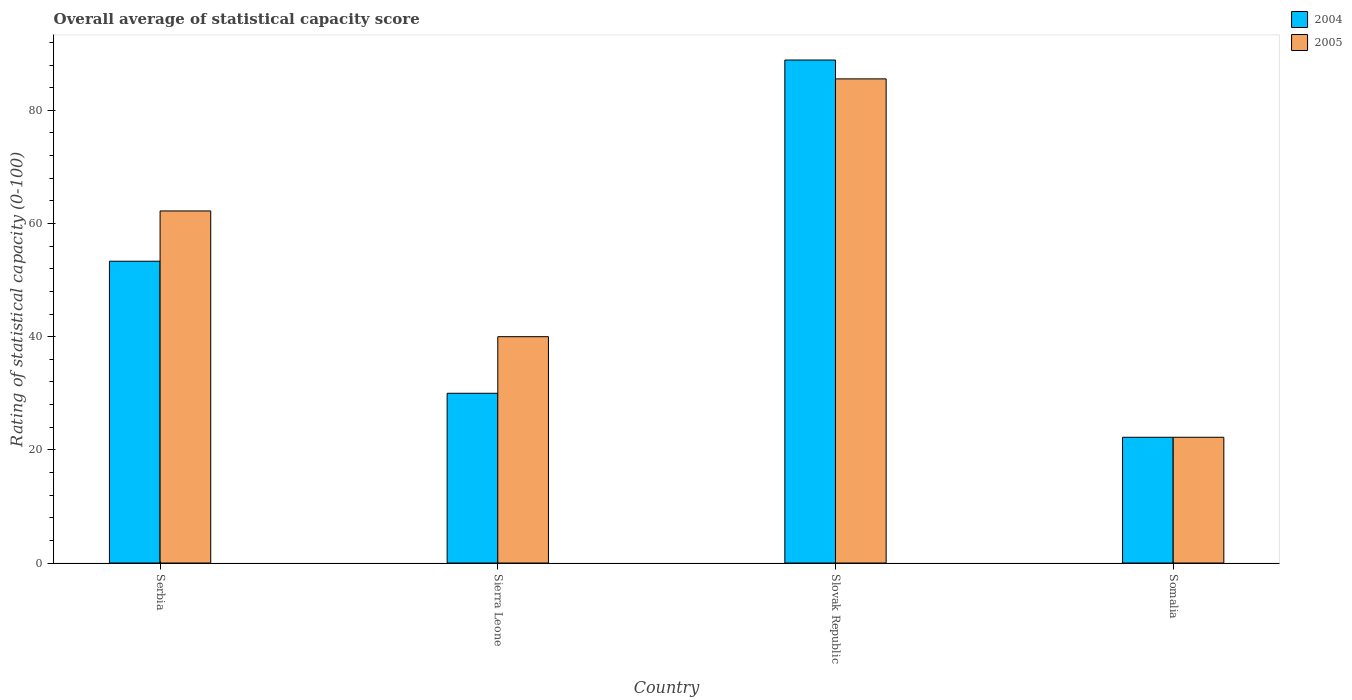How many different coloured bars are there?
Give a very brief answer. 2. How many groups of bars are there?
Your answer should be compact. 4. How many bars are there on the 1st tick from the left?
Give a very brief answer. 2. How many bars are there on the 1st tick from the right?
Your answer should be very brief. 2. What is the label of the 4th group of bars from the left?
Your answer should be compact. Somalia. In how many cases, is the number of bars for a given country not equal to the number of legend labels?
Give a very brief answer. 0. What is the rating of statistical capacity in 2005 in Slovak Republic?
Your answer should be compact. 85.56. Across all countries, what is the maximum rating of statistical capacity in 2004?
Offer a very short reply. 88.89. Across all countries, what is the minimum rating of statistical capacity in 2004?
Ensure brevity in your answer.  22.22. In which country was the rating of statistical capacity in 2005 maximum?
Provide a succinct answer. Slovak Republic. In which country was the rating of statistical capacity in 2005 minimum?
Ensure brevity in your answer.  Somalia. What is the total rating of statistical capacity in 2004 in the graph?
Your answer should be very brief. 194.44. What is the difference between the rating of statistical capacity in 2004 in Slovak Republic and that in Somalia?
Your answer should be compact. 66.67. What is the difference between the rating of statistical capacity in 2004 in Sierra Leone and the rating of statistical capacity in 2005 in Somalia?
Make the answer very short. 7.78. What is the average rating of statistical capacity in 2005 per country?
Ensure brevity in your answer.  52.5. What is the difference between the rating of statistical capacity of/in 2004 and rating of statistical capacity of/in 2005 in Serbia?
Offer a very short reply. -8.89. In how many countries, is the rating of statistical capacity in 2005 greater than 52?
Make the answer very short. 2. What is the ratio of the rating of statistical capacity in 2004 in Sierra Leone to that in Somalia?
Offer a very short reply. 1.35. Is the rating of statistical capacity in 2004 in Serbia less than that in Slovak Republic?
Your response must be concise. Yes. Is the difference between the rating of statistical capacity in 2004 in Sierra Leone and Slovak Republic greater than the difference between the rating of statistical capacity in 2005 in Sierra Leone and Slovak Republic?
Your answer should be compact. No. What is the difference between the highest and the second highest rating of statistical capacity in 2005?
Provide a short and direct response. -45.56. What is the difference between the highest and the lowest rating of statistical capacity in 2005?
Offer a very short reply. 63.33. What does the 1st bar from the left in Sierra Leone represents?
Ensure brevity in your answer.  2004. How many countries are there in the graph?
Ensure brevity in your answer.  4. Are the values on the major ticks of Y-axis written in scientific E-notation?
Your answer should be compact. No. Does the graph contain grids?
Offer a terse response. No. Where does the legend appear in the graph?
Provide a succinct answer. Top right. How are the legend labels stacked?
Keep it short and to the point. Vertical. What is the title of the graph?
Provide a short and direct response. Overall average of statistical capacity score. Does "1973" appear as one of the legend labels in the graph?
Ensure brevity in your answer.  No. What is the label or title of the Y-axis?
Make the answer very short. Rating of statistical capacity (0-100). What is the Rating of statistical capacity (0-100) of 2004 in Serbia?
Ensure brevity in your answer.  53.33. What is the Rating of statistical capacity (0-100) in 2005 in Serbia?
Make the answer very short. 62.22. What is the Rating of statistical capacity (0-100) of 2005 in Sierra Leone?
Provide a succinct answer. 40. What is the Rating of statistical capacity (0-100) in 2004 in Slovak Republic?
Your response must be concise. 88.89. What is the Rating of statistical capacity (0-100) of 2005 in Slovak Republic?
Provide a succinct answer. 85.56. What is the Rating of statistical capacity (0-100) of 2004 in Somalia?
Your answer should be compact. 22.22. What is the Rating of statistical capacity (0-100) in 2005 in Somalia?
Your response must be concise. 22.22. Across all countries, what is the maximum Rating of statistical capacity (0-100) of 2004?
Your answer should be very brief. 88.89. Across all countries, what is the maximum Rating of statistical capacity (0-100) in 2005?
Provide a succinct answer. 85.56. Across all countries, what is the minimum Rating of statistical capacity (0-100) of 2004?
Make the answer very short. 22.22. Across all countries, what is the minimum Rating of statistical capacity (0-100) in 2005?
Your answer should be very brief. 22.22. What is the total Rating of statistical capacity (0-100) in 2004 in the graph?
Your response must be concise. 194.44. What is the total Rating of statistical capacity (0-100) of 2005 in the graph?
Give a very brief answer. 210. What is the difference between the Rating of statistical capacity (0-100) in 2004 in Serbia and that in Sierra Leone?
Make the answer very short. 23.33. What is the difference between the Rating of statistical capacity (0-100) in 2005 in Serbia and that in Sierra Leone?
Give a very brief answer. 22.22. What is the difference between the Rating of statistical capacity (0-100) of 2004 in Serbia and that in Slovak Republic?
Your response must be concise. -35.56. What is the difference between the Rating of statistical capacity (0-100) in 2005 in Serbia and that in Slovak Republic?
Provide a succinct answer. -23.34. What is the difference between the Rating of statistical capacity (0-100) of 2004 in Serbia and that in Somalia?
Give a very brief answer. 31.11. What is the difference between the Rating of statistical capacity (0-100) of 2005 in Serbia and that in Somalia?
Your answer should be compact. 40. What is the difference between the Rating of statistical capacity (0-100) in 2004 in Sierra Leone and that in Slovak Republic?
Ensure brevity in your answer.  -58.89. What is the difference between the Rating of statistical capacity (0-100) in 2005 in Sierra Leone and that in Slovak Republic?
Provide a short and direct response. -45.56. What is the difference between the Rating of statistical capacity (0-100) of 2004 in Sierra Leone and that in Somalia?
Provide a short and direct response. 7.78. What is the difference between the Rating of statistical capacity (0-100) of 2005 in Sierra Leone and that in Somalia?
Make the answer very short. 17.78. What is the difference between the Rating of statistical capacity (0-100) of 2004 in Slovak Republic and that in Somalia?
Give a very brief answer. 66.67. What is the difference between the Rating of statistical capacity (0-100) in 2005 in Slovak Republic and that in Somalia?
Make the answer very short. 63.33. What is the difference between the Rating of statistical capacity (0-100) of 2004 in Serbia and the Rating of statistical capacity (0-100) of 2005 in Sierra Leone?
Make the answer very short. 13.33. What is the difference between the Rating of statistical capacity (0-100) in 2004 in Serbia and the Rating of statistical capacity (0-100) in 2005 in Slovak Republic?
Provide a succinct answer. -32.22. What is the difference between the Rating of statistical capacity (0-100) of 2004 in Serbia and the Rating of statistical capacity (0-100) of 2005 in Somalia?
Your answer should be very brief. 31.11. What is the difference between the Rating of statistical capacity (0-100) in 2004 in Sierra Leone and the Rating of statistical capacity (0-100) in 2005 in Slovak Republic?
Offer a very short reply. -55.56. What is the difference between the Rating of statistical capacity (0-100) in 2004 in Sierra Leone and the Rating of statistical capacity (0-100) in 2005 in Somalia?
Keep it short and to the point. 7.78. What is the difference between the Rating of statistical capacity (0-100) of 2004 in Slovak Republic and the Rating of statistical capacity (0-100) of 2005 in Somalia?
Your response must be concise. 66.67. What is the average Rating of statistical capacity (0-100) of 2004 per country?
Your response must be concise. 48.61. What is the average Rating of statistical capacity (0-100) of 2005 per country?
Provide a succinct answer. 52.5. What is the difference between the Rating of statistical capacity (0-100) of 2004 and Rating of statistical capacity (0-100) of 2005 in Serbia?
Provide a succinct answer. -8.89. What is the difference between the Rating of statistical capacity (0-100) of 2004 and Rating of statistical capacity (0-100) of 2005 in Sierra Leone?
Provide a succinct answer. -10. What is the difference between the Rating of statistical capacity (0-100) in 2004 and Rating of statistical capacity (0-100) in 2005 in Slovak Republic?
Offer a very short reply. 3.33. What is the difference between the Rating of statistical capacity (0-100) of 2004 and Rating of statistical capacity (0-100) of 2005 in Somalia?
Make the answer very short. 0. What is the ratio of the Rating of statistical capacity (0-100) of 2004 in Serbia to that in Sierra Leone?
Your answer should be compact. 1.78. What is the ratio of the Rating of statistical capacity (0-100) in 2005 in Serbia to that in Sierra Leone?
Your answer should be compact. 1.56. What is the ratio of the Rating of statistical capacity (0-100) of 2005 in Serbia to that in Slovak Republic?
Make the answer very short. 0.73. What is the ratio of the Rating of statistical capacity (0-100) in 2005 in Serbia to that in Somalia?
Make the answer very short. 2.8. What is the ratio of the Rating of statistical capacity (0-100) of 2004 in Sierra Leone to that in Slovak Republic?
Provide a succinct answer. 0.34. What is the ratio of the Rating of statistical capacity (0-100) of 2005 in Sierra Leone to that in Slovak Republic?
Provide a succinct answer. 0.47. What is the ratio of the Rating of statistical capacity (0-100) in 2004 in Sierra Leone to that in Somalia?
Your answer should be very brief. 1.35. What is the ratio of the Rating of statistical capacity (0-100) of 2005 in Sierra Leone to that in Somalia?
Your answer should be compact. 1.8. What is the ratio of the Rating of statistical capacity (0-100) of 2004 in Slovak Republic to that in Somalia?
Provide a short and direct response. 4. What is the ratio of the Rating of statistical capacity (0-100) of 2005 in Slovak Republic to that in Somalia?
Keep it short and to the point. 3.85. What is the difference between the highest and the second highest Rating of statistical capacity (0-100) of 2004?
Offer a terse response. 35.56. What is the difference between the highest and the second highest Rating of statistical capacity (0-100) in 2005?
Your response must be concise. 23.34. What is the difference between the highest and the lowest Rating of statistical capacity (0-100) in 2004?
Your answer should be very brief. 66.67. What is the difference between the highest and the lowest Rating of statistical capacity (0-100) of 2005?
Your answer should be very brief. 63.33. 